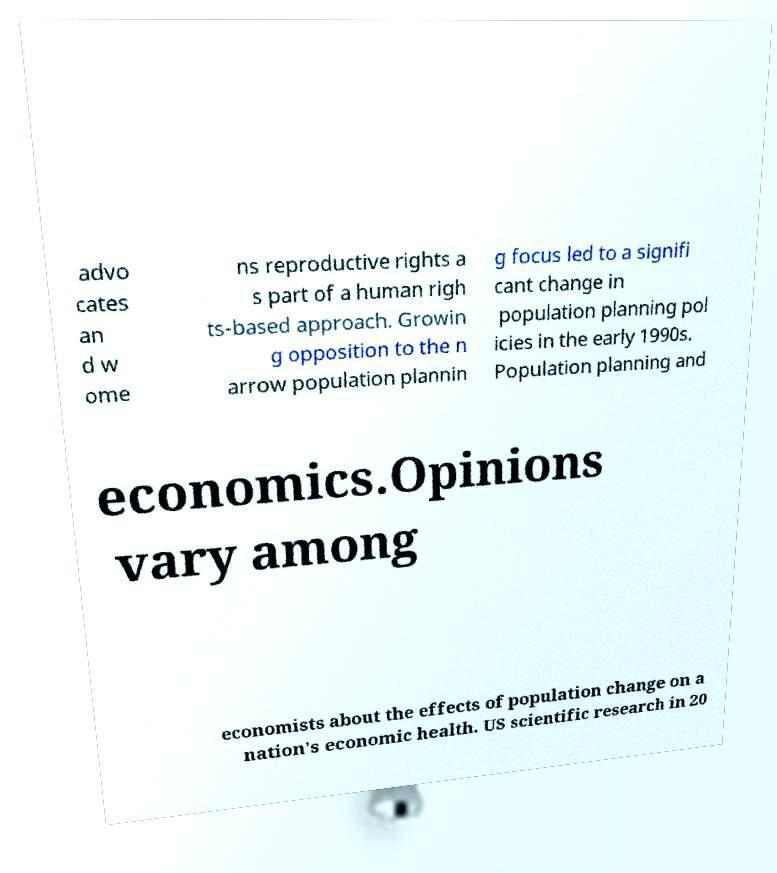There's text embedded in this image that I need extracted. Can you transcribe it verbatim? advo cates an d w ome ns reproductive rights a s part of a human righ ts-based approach. Growin g opposition to the n arrow population plannin g focus led to a signifi cant change in population planning pol icies in the early 1990s. Population planning and economics.Opinions vary among economists about the effects of population change on a nation's economic health. US scientific research in 20 